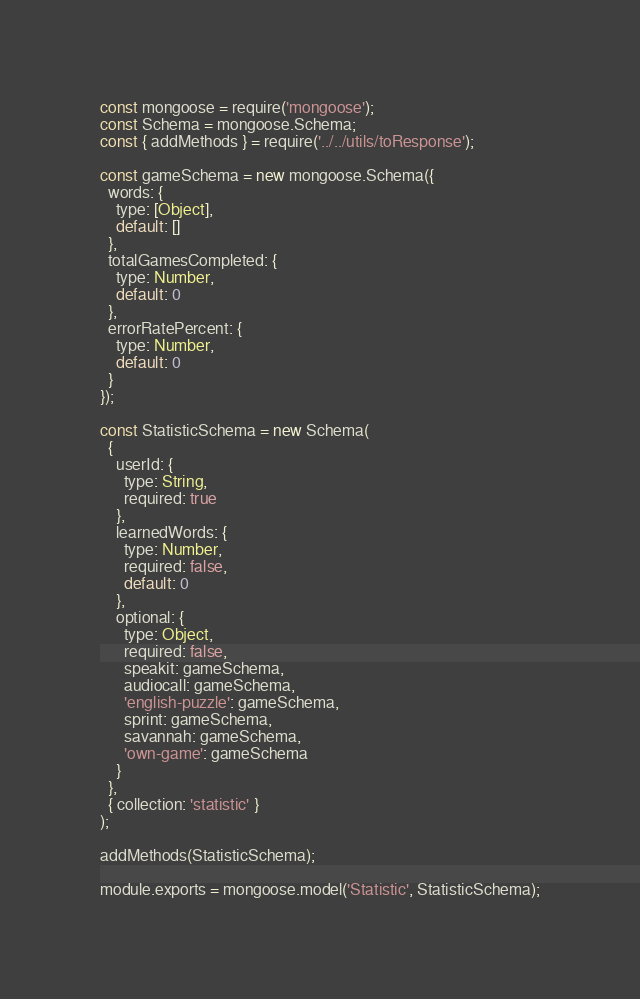Convert code to text. <code><loc_0><loc_0><loc_500><loc_500><_JavaScript_>const mongoose = require('mongoose');
const Schema = mongoose.Schema;
const { addMethods } = require('../../utils/toResponse');

const gameSchema = new mongoose.Schema({
  words: {
    type: [Object],
    default: []
  },
  totalGamesCompleted: {
    type: Number,
    default: 0
  },
  errorRatePercent: {
    type: Number,
    default: 0
  }
});

const StatisticSchema = new Schema(
  {
    userId: {
      type: String,
      required: true
    },
    learnedWords: {
      type: Number,
      required: false,
      default: 0
    },
    optional: {
      type: Object,
      required: false,
      speakit: gameSchema,
      audiocall: gameSchema,
      'english-puzzle': gameSchema,
      sprint: gameSchema,
      savannah: gameSchema,
      'own-game': gameSchema
    }
  },
  { collection: 'statistic' }
);

addMethods(StatisticSchema);

module.exports = mongoose.model('Statistic', StatisticSchema);
</code> 